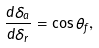Convert formula to latex. <formula><loc_0><loc_0><loc_500><loc_500>\frac { d \delta _ { a } } { d \delta _ { r } } = \cos \theta _ { f } ,</formula> 